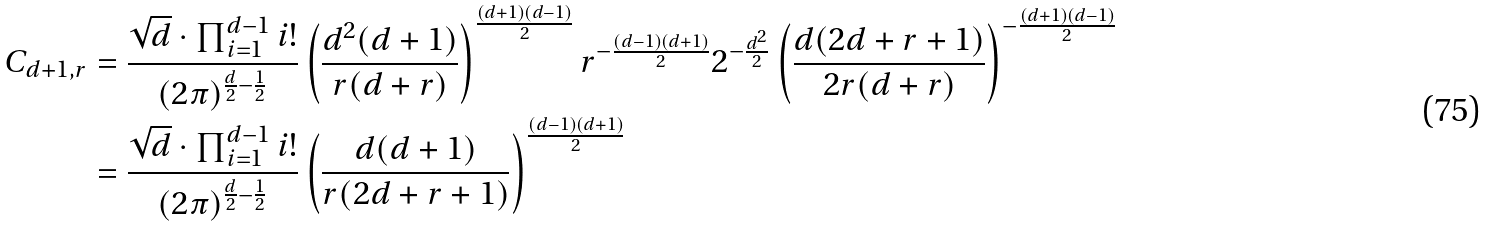Convert formula to latex. <formula><loc_0><loc_0><loc_500><loc_500>C _ { d + 1 , r } & = \frac { \sqrt { d } \cdot \prod _ { i = 1 } ^ { d - 1 } i ! } { ( 2 \pi ) ^ { \frac { d } { 2 } - \frac { 1 } { 2 } } } \left ( \frac { d ^ { 2 } ( d + 1 ) } { r ( d + r ) } \right ) ^ { \frac { ( d + 1 ) ( d - 1 ) } { 2 } } r ^ { - \frac { ( d - 1 ) ( d + 1 ) } { 2 } } 2 ^ { - \frac { d ^ { 2 } } { 2 } } \left ( \frac { d ( 2 d + r + 1 ) } { 2 r ( d + r ) } \right ) ^ { - \frac { ( d + 1 ) ( d - 1 ) } { 2 } } \\ & = \frac { \sqrt { d } \cdot \prod _ { i = 1 } ^ { d - 1 } i ! } { ( 2 \pi ) ^ { \frac { d } { 2 } - \frac { 1 } { 2 } } } \left ( \frac { d ( d + 1 ) } { r ( 2 d + r + 1 ) } \right ) ^ { \frac { ( d - 1 ) ( d + 1 ) } { 2 } }</formula> 